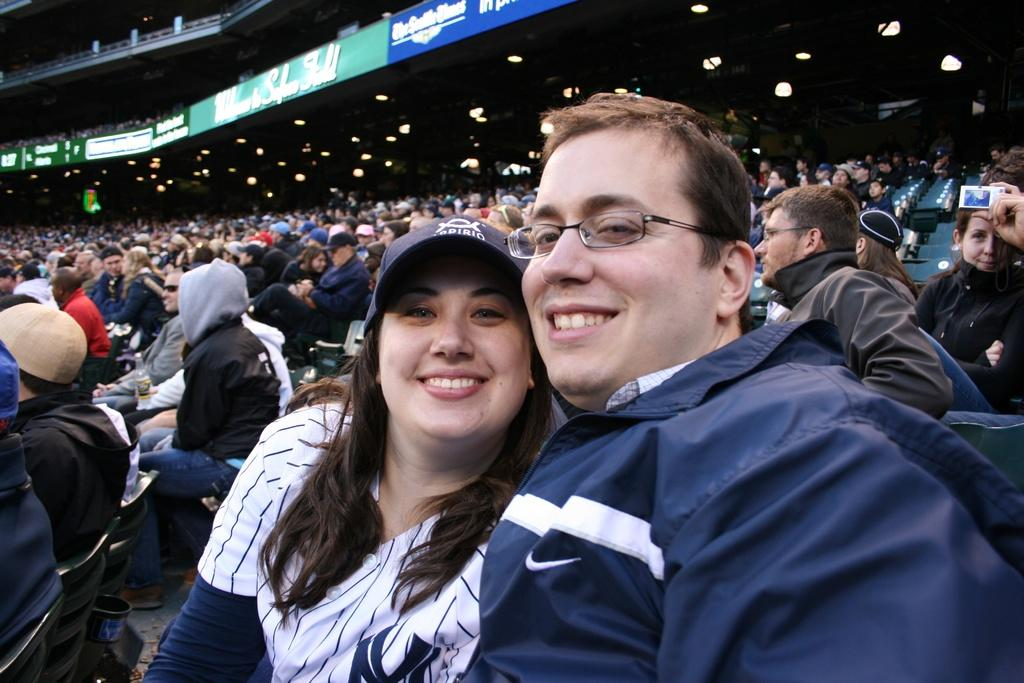How many people are present in the image? There are many people in the image. What can be observed about the clothing of the people in the image? The people are wearing different color dresses. Are there any accessories visible on the people in the image? Yes, some people are wearing caps. What can be seen in the background of the image? There are boards, lights, and a railing in the background of the image. How does the collar of the dresses help the people stay dry during the rainstorm in the image? There is no rainstorm present in the image, and therefore no need for collars to help the people stay dry. 